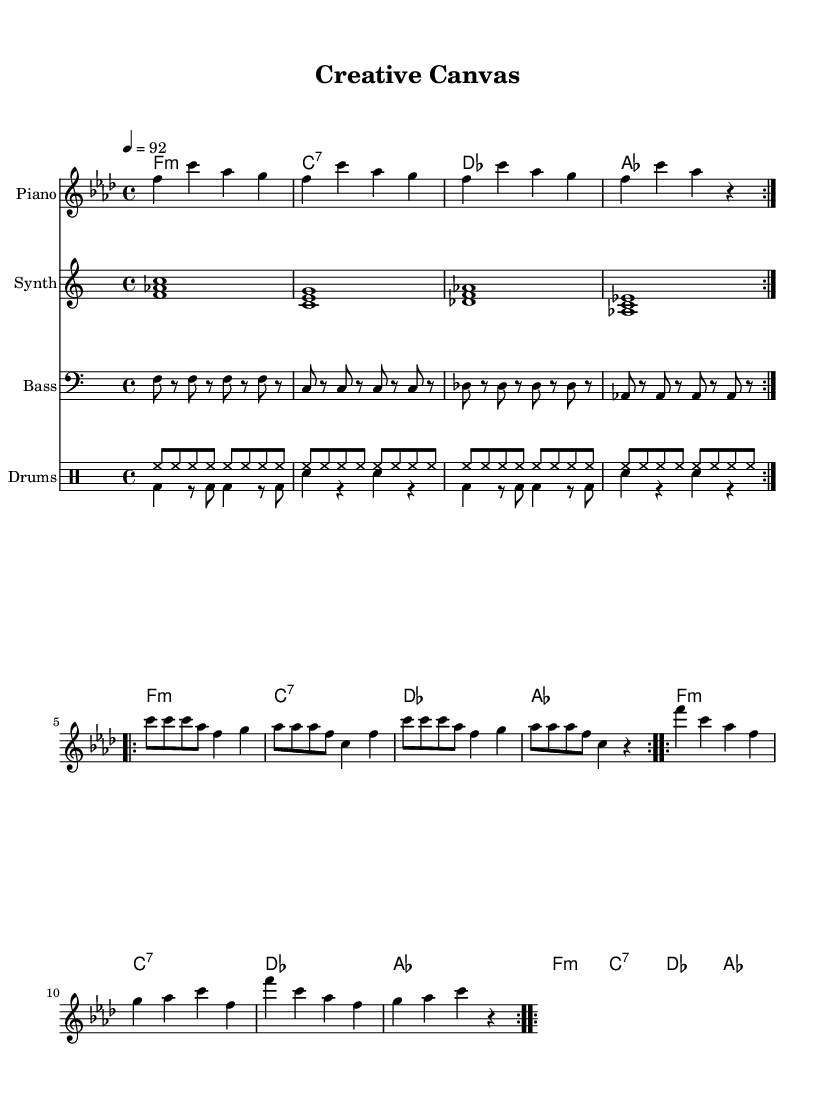What is the key signature of this music? The key signature shows four flats, indicating that the piece is in F minor.
Answer: F minor What is the time signature of this composition? The time signature is located at the beginning of the score and indicates 4/4 time, meaning there are four beats in each measure.
Answer: 4/4 What is the tempo marking for this piece? The tempo marking is indicated as "4 = 92," which shows that the quarter note gets a beat of 92 beats per minute.
Answer: 92 How many measures are there in the melody section? By counting the measures in the melody part, I find there are 24 measures in total displayed.
Answer: 24 Which instruments are featured in this score? The score layout shows that there are sections for Piano, Synth, Bass, and Drums, clearly indicating all instruments involved.
Answer: Piano, Synth, Bass, Drums What type of chords are used in the progression? The harmony section indicates the chord types as minor and dominant seventh (e.g., F minor, C7) used in combination throughout the progression.
Answer: minor, seventh Is there a variation in the drum patterns? The drum patterns include two distinct parts: one for a hi-hat rhythm repeated and another featuring bass and snare, showcasing change in style.
Answer: Yes 